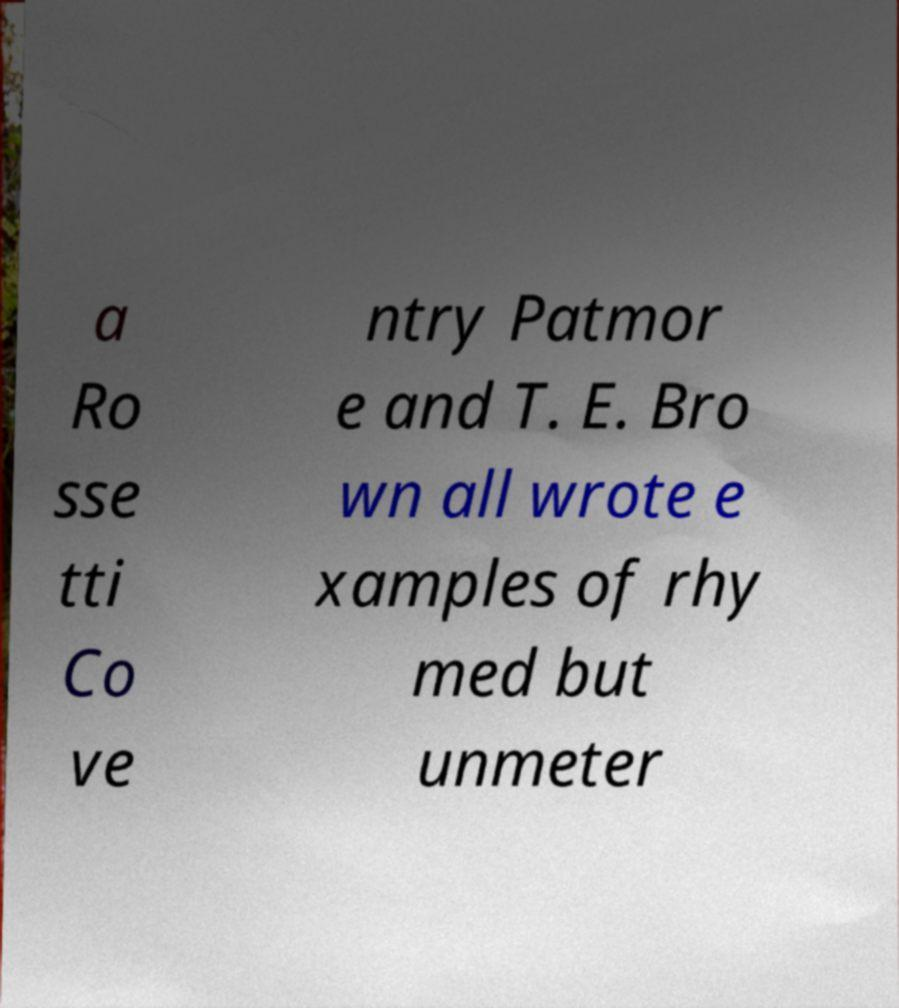Can you accurately transcribe the text from the provided image for me? a Ro sse tti Co ve ntry Patmor e and T. E. Bro wn all wrote e xamples of rhy med but unmeter 